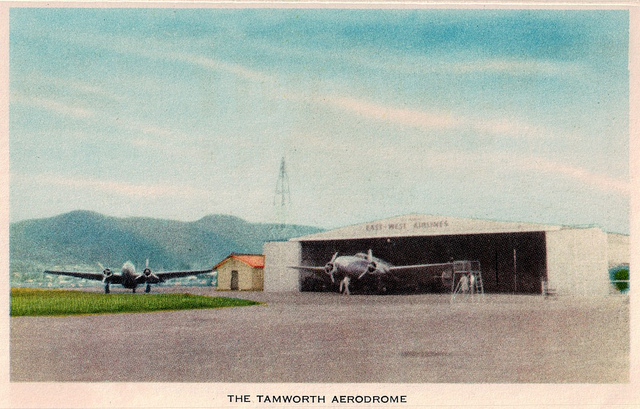<image>Who gave permission to reproduce the photograph in Figure 1? It is unknown who gave permission to reproduce the photograph in Figure 1. It could possibly be 'tamworth aerodrome'. Who gave permission to reproduce the photograph in Figure 1? I don't know who gave permission to reproduce the photograph in Figure 1. It could be Tamworth Aerodrome, but I am not sure. 